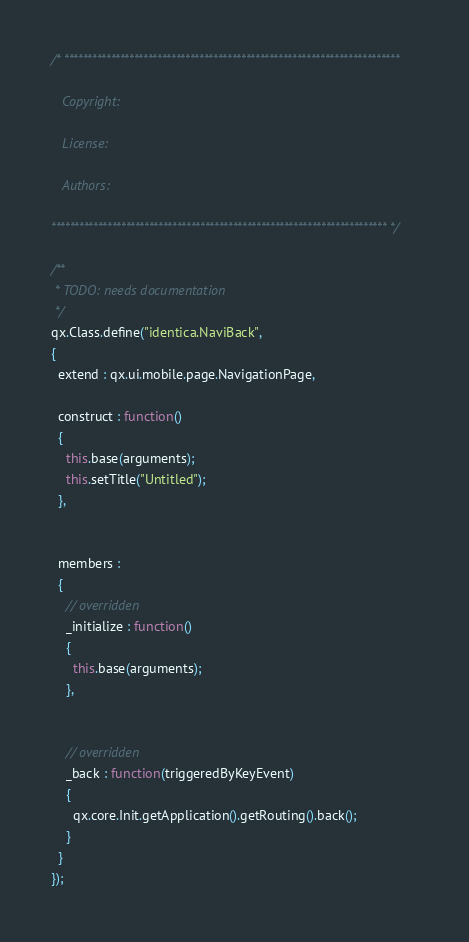<code> <loc_0><loc_0><loc_500><loc_500><_JavaScript_>/* ************************************************************************

   Copyright:

   License:

   Authors:

************************************************************************ */

/**
 * TODO: needs documentation
 */
qx.Class.define("identica.NaviBack",
{
  extend : qx.ui.mobile.page.NavigationPage,

  construct : function()
  {
    this.base(arguments);
    this.setTitle("Untitled");
  },


  members :
  {
    // overridden
    _initialize : function()
    {
      this.base(arguments);
    },


    // overridden
    _back : function(triggeredByKeyEvent)
    {
      qx.core.Init.getApplication().getRouting().back();
    }
  }
});
</code> 